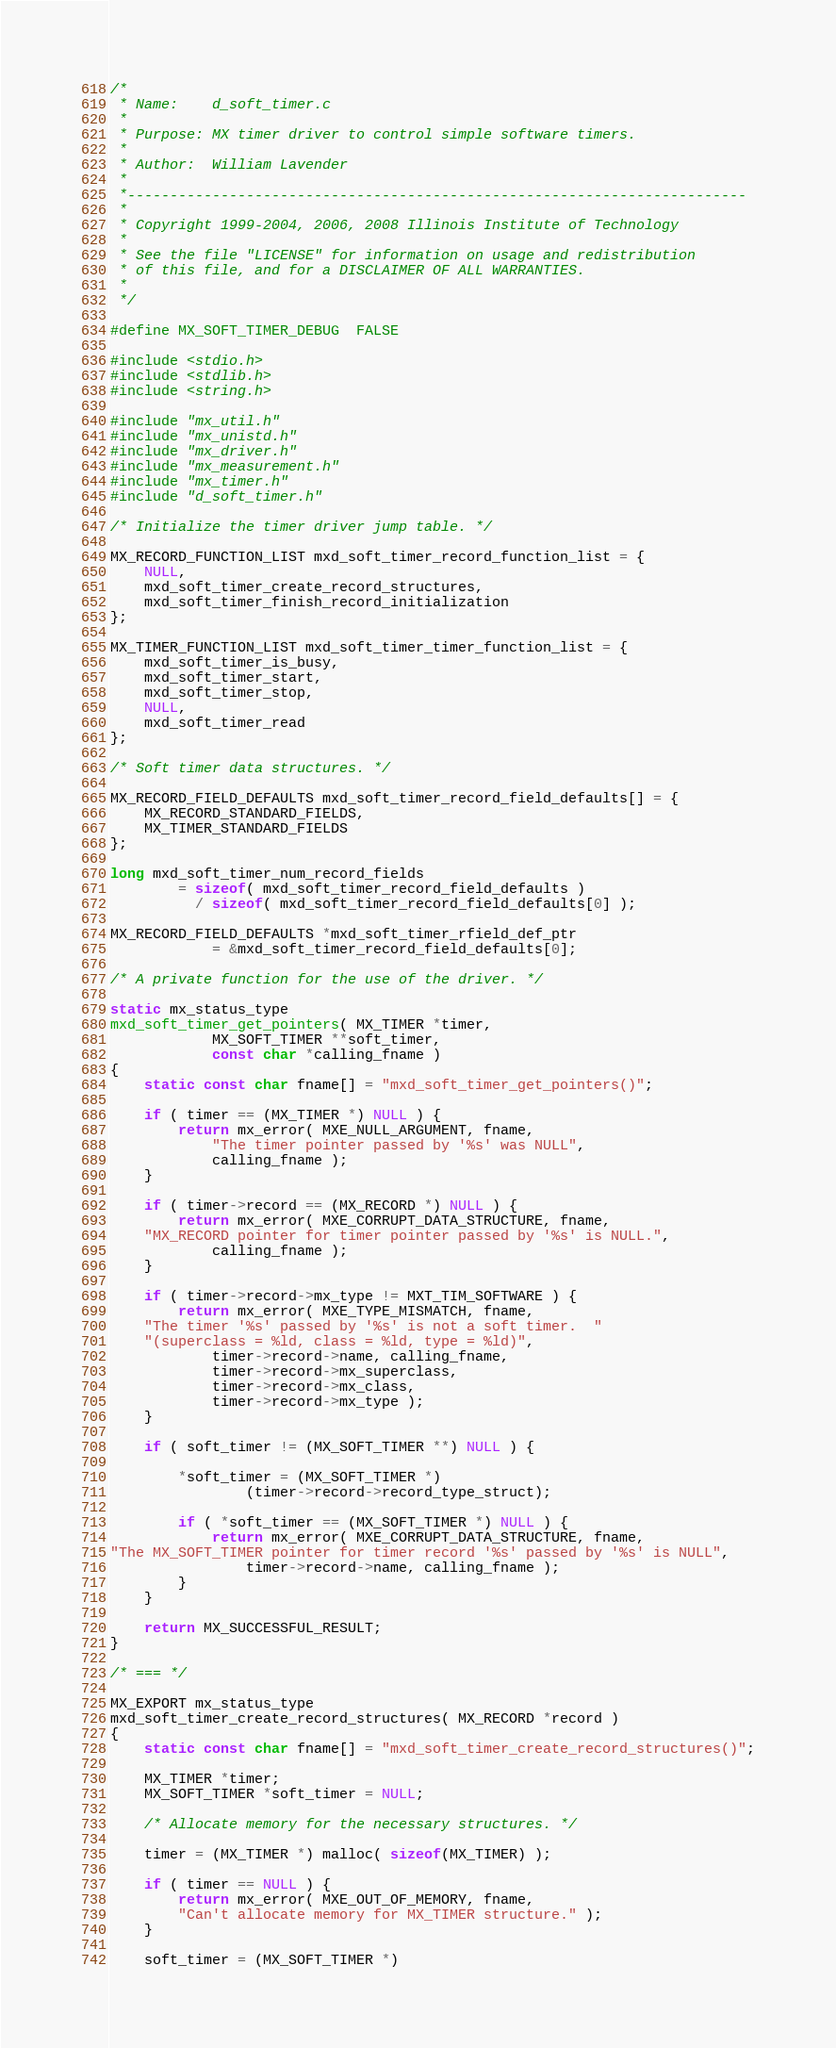Convert code to text. <code><loc_0><loc_0><loc_500><loc_500><_C_>/*
 * Name:    d_soft_timer.c
 *
 * Purpose: MX timer driver to control simple software timers.
 *
 * Author:  William Lavender
 *
 *-------------------------------------------------------------------------
 *
 * Copyright 1999-2004, 2006, 2008 Illinois Institute of Technology
 *
 * See the file "LICENSE" for information on usage and redistribution
 * of this file, and for a DISCLAIMER OF ALL WARRANTIES.
 *
 */

#define MX_SOFT_TIMER_DEBUG	FALSE

#include <stdio.h>
#include <stdlib.h>
#include <string.h>

#include "mx_util.h"
#include "mx_unistd.h"
#include "mx_driver.h"
#include "mx_measurement.h"
#include "mx_timer.h"
#include "d_soft_timer.h"

/* Initialize the timer driver jump table. */

MX_RECORD_FUNCTION_LIST mxd_soft_timer_record_function_list = {
	NULL,
	mxd_soft_timer_create_record_structures,
	mxd_soft_timer_finish_record_initialization
};

MX_TIMER_FUNCTION_LIST mxd_soft_timer_timer_function_list = {
	mxd_soft_timer_is_busy,
	mxd_soft_timer_start,
	mxd_soft_timer_stop,
	NULL,
	mxd_soft_timer_read
};

/* Soft timer data structures. */

MX_RECORD_FIELD_DEFAULTS mxd_soft_timer_record_field_defaults[] = {
	MX_RECORD_STANDARD_FIELDS,
	MX_TIMER_STANDARD_FIELDS
};

long mxd_soft_timer_num_record_fields
		= sizeof( mxd_soft_timer_record_field_defaults )
		  / sizeof( mxd_soft_timer_record_field_defaults[0] );

MX_RECORD_FIELD_DEFAULTS *mxd_soft_timer_rfield_def_ptr
			= &mxd_soft_timer_record_field_defaults[0];

/* A private function for the use of the driver. */

static mx_status_type
mxd_soft_timer_get_pointers( MX_TIMER *timer,
			MX_SOFT_TIMER **soft_timer,
			const char *calling_fname )
{
	static const char fname[] = "mxd_soft_timer_get_pointers()";

	if ( timer == (MX_TIMER *) NULL ) {
		return mx_error( MXE_NULL_ARGUMENT, fname,
			"The timer pointer passed by '%s' was NULL",
			calling_fname );
	}

	if ( timer->record == (MX_RECORD *) NULL ) {
		return mx_error( MXE_CORRUPT_DATA_STRUCTURE, fname,
	"MX_RECORD pointer for timer pointer passed by '%s' is NULL.",
			calling_fname );
	}

	if ( timer->record->mx_type != MXT_TIM_SOFTWARE ) {
		return mx_error( MXE_TYPE_MISMATCH, fname,
	"The timer '%s' passed by '%s' is not a soft timer.  "
	"(superclass = %ld, class = %ld, type = %ld)",
			timer->record->name, calling_fname,
			timer->record->mx_superclass,
			timer->record->mx_class,
			timer->record->mx_type );
	}

	if ( soft_timer != (MX_SOFT_TIMER **) NULL ) {

		*soft_timer = (MX_SOFT_TIMER *)
				(timer->record->record_type_struct);

		if ( *soft_timer == (MX_SOFT_TIMER *) NULL ) {
			return mx_error( MXE_CORRUPT_DATA_STRUCTURE, fname,
"The MX_SOFT_TIMER pointer for timer record '%s' passed by '%s' is NULL",
				timer->record->name, calling_fname );
		}
	}

	return MX_SUCCESSFUL_RESULT;
}

/* === */

MX_EXPORT mx_status_type
mxd_soft_timer_create_record_structures( MX_RECORD *record )
{
	static const char fname[] = "mxd_soft_timer_create_record_structures()";

	MX_TIMER *timer;
	MX_SOFT_TIMER *soft_timer = NULL;

	/* Allocate memory for the necessary structures. */

	timer = (MX_TIMER *) malloc( sizeof(MX_TIMER) );

	if ( timer == NULL ) {
		return mx_error( MXE_OUT_OF_MEMORY, fname,
		"Can't allocate memory for MX_TIMER structure." );
	}

	soft_timer = (MX_SOFT_TIMER *)</code> 